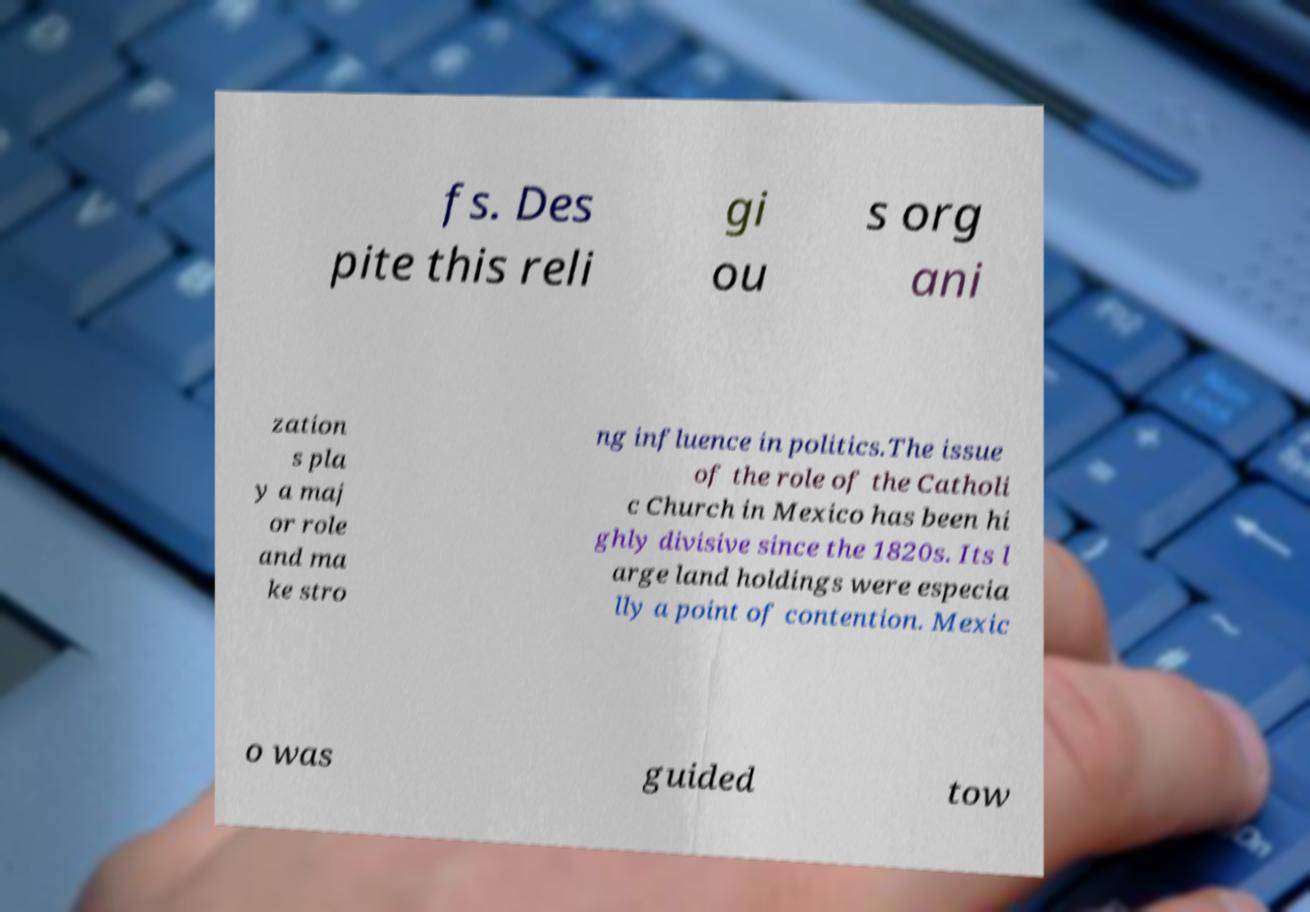Can you read and provide the text displayed in the image?This photo seems to have some interesting text. Can you extract and type it out for me? fs. Des pite this reli gi ou s org ani zation s pla y a maj or role and ma ke stro ng influence in politics.The issue of the role of the Catholi c Church in Mexico has been hi ghly divisive since the 1820s. Its l arge land holdings were especia lly a point of contention. Mexic o was guided tow 